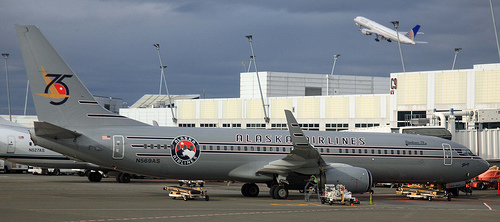Is there any closed window or door? Yes, the aircraft has several closed windows and the boarding door also appears to be closed. 